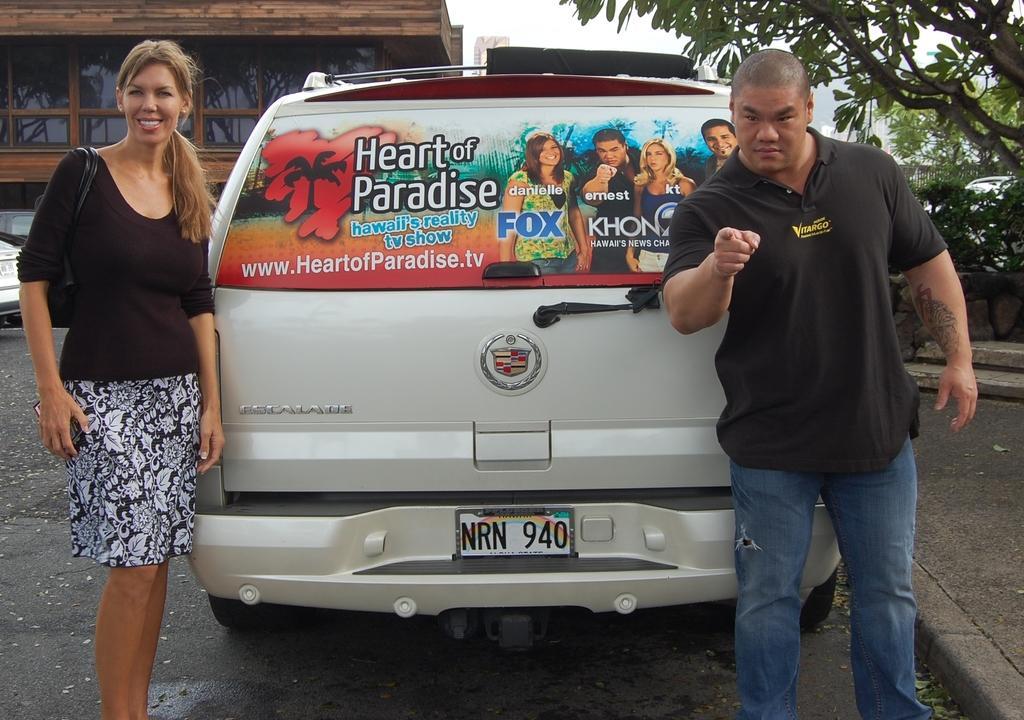Could you give a brief overview of what you see in this image? In the picture we can see a man and a woman are standing behind the car on the each corner and woman is in black top with a hand bag and she is smiling and man is in black T-shirt and showing his hand and finger and in the background we can see a wooden house with glasses to it and near to it we can see some vehicles are parked and besides we can see some plants and trees on the path. 